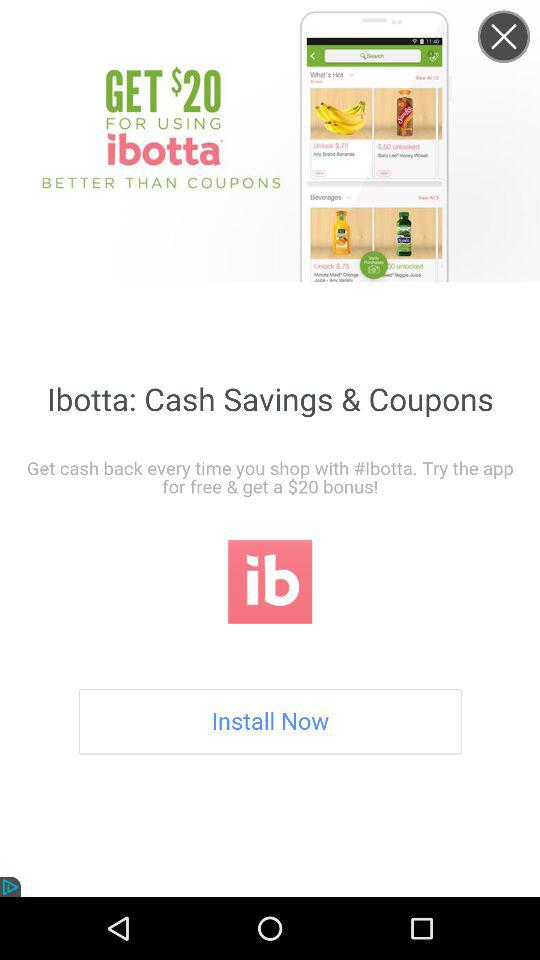How much money can I save if I use ibotta?
Answer the question using a single word or phrase. $20 